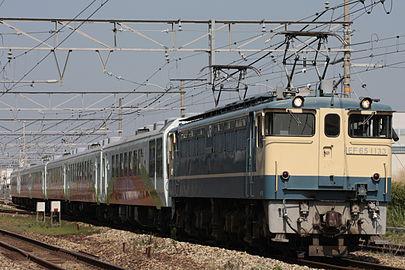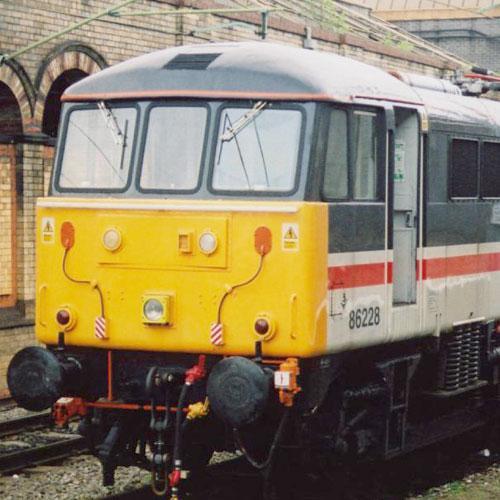The first image is the image on the left, the second image is the image on the right. Considering the images on both sides, is "The train in the right image is painted yellow in the front." valid? Answer yes or no. Yes. The first image is the image on the left, the second image is the image on the right. Given the left and right images, does the statement "The train in one of the images has just come around a bend." hold true? Answer yes or no. No. 